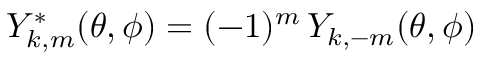Convert formula to latex. <formula><loc_0><loc_0><loc_500><loc_500>{ Y _ { k , m } ^ { * } ( \theta , \phi ) = ( - 1 ) ^ { m } \, Y _ { k , - m } ( \theta , \phi ) }</formula> 